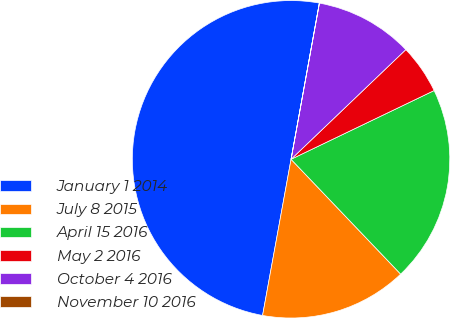Convert chart. <chart><loc_0><loc_0><loc_500><loc_500><pie_chart><fcel>January 1 2014<fcel>July 8 2015<fcel>April 15 2016<fcel>May 2 2016<fcel>October 4 2016<fcel>November 10 2016<nl><fcel>49.98%<fcel>15.0%<fcel>20.0%<fcel>5.01%<fcel>10.0%<fcel>0.01%<nl></chart> 